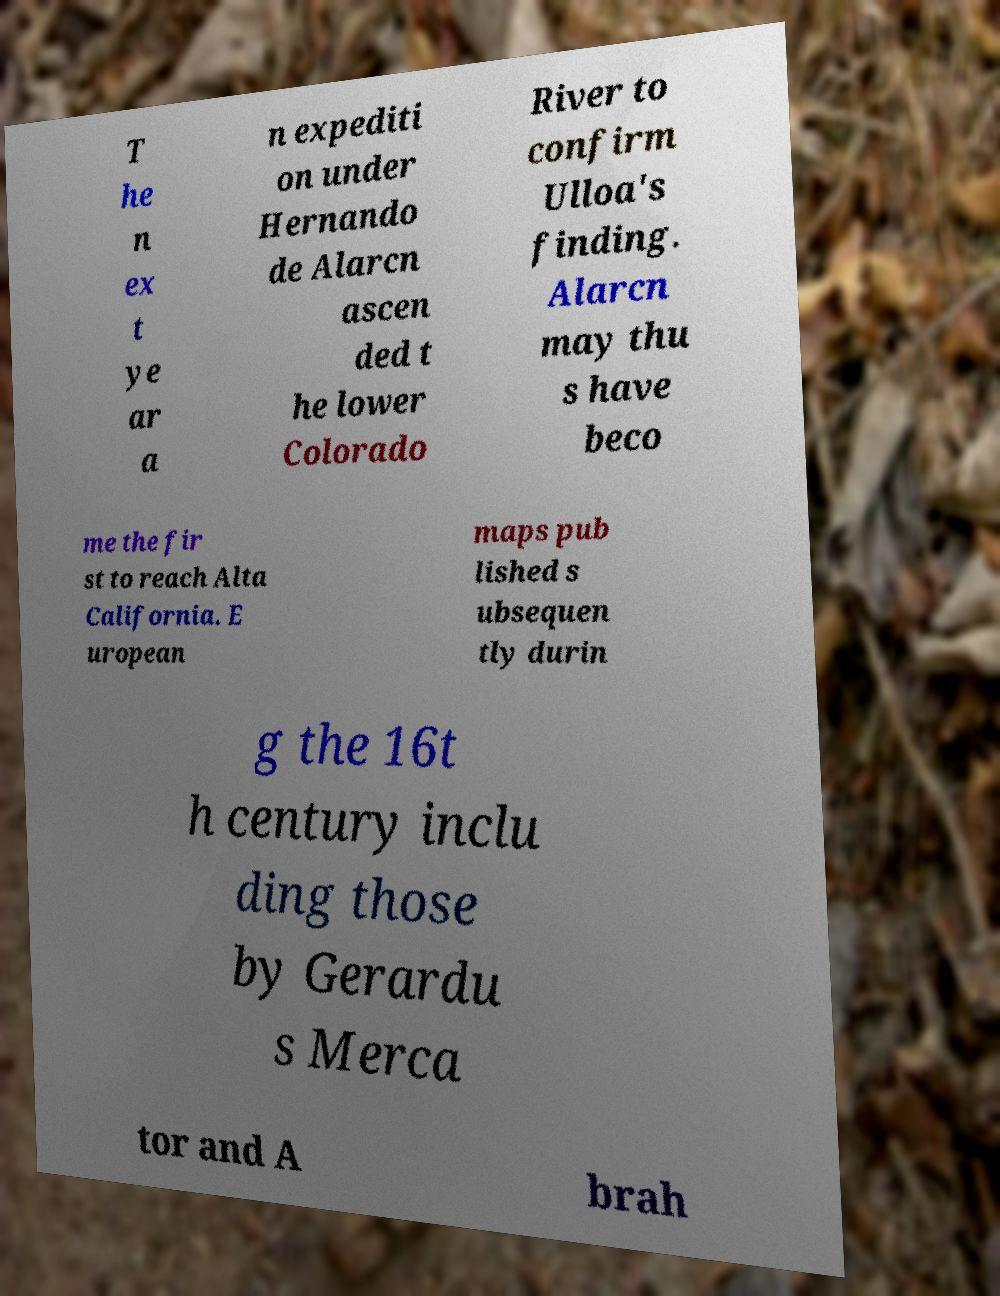Could you assist in decoding the text presented in this image and type it out clearly? T he n ex t ye ar a n expediti on under Hernando de Alarcn ascen ded t he lower Colorado River to confirm Ulloa's finding. Alarcn may thu s have beco me the fir st to reach Alta California. E uropean maps pub lished s ubsequen tly durin g the 16t h century inclu ding those by Gerardu s Merca tor and A brah 